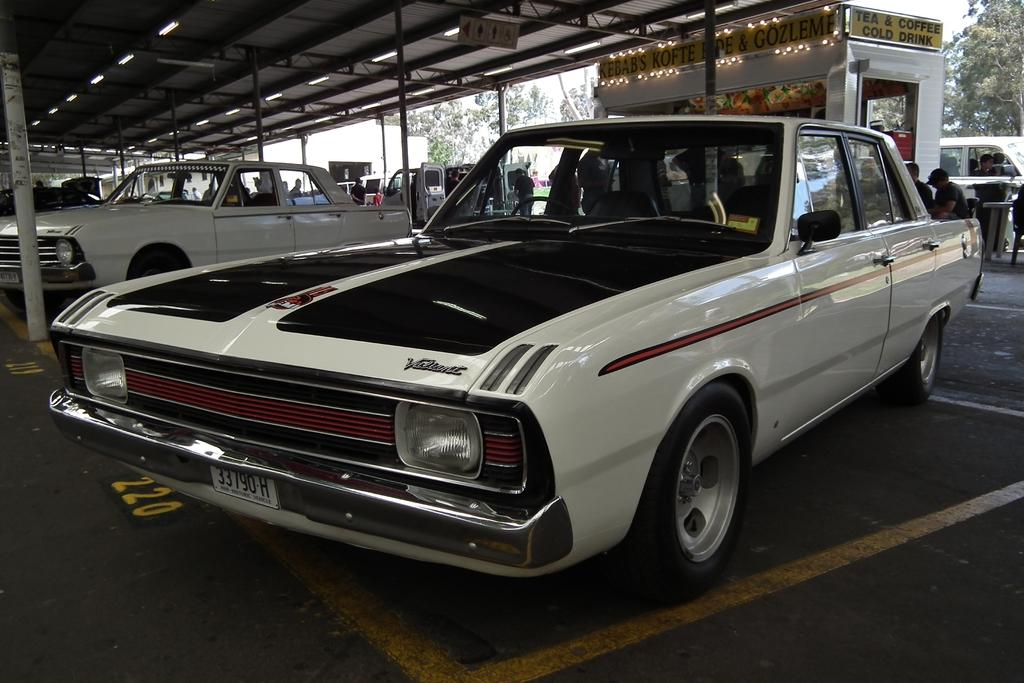What can be seen in large numbers in the image? There are many cars in the image. What structure is visible in the background of the image? There is a shed in the background of the image. What is written on the shed? Something is written on the shed. What type of lighting is present in the image? There are lights on the ceiling. What type of natural environment is visible in the background of the image? Trees are visible in the background of the image. Are there any living beings in the image? Yes, there are people in the image. Can you see a bear reading a book in the image? No, there is no bear or book present in the image. Are there any rabbits visible in the image? No, there are no rabbits present in the image. 